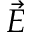<formula> <loc_0><loc_0><loc_500><loc_500>\ V e c { E }</formula> 